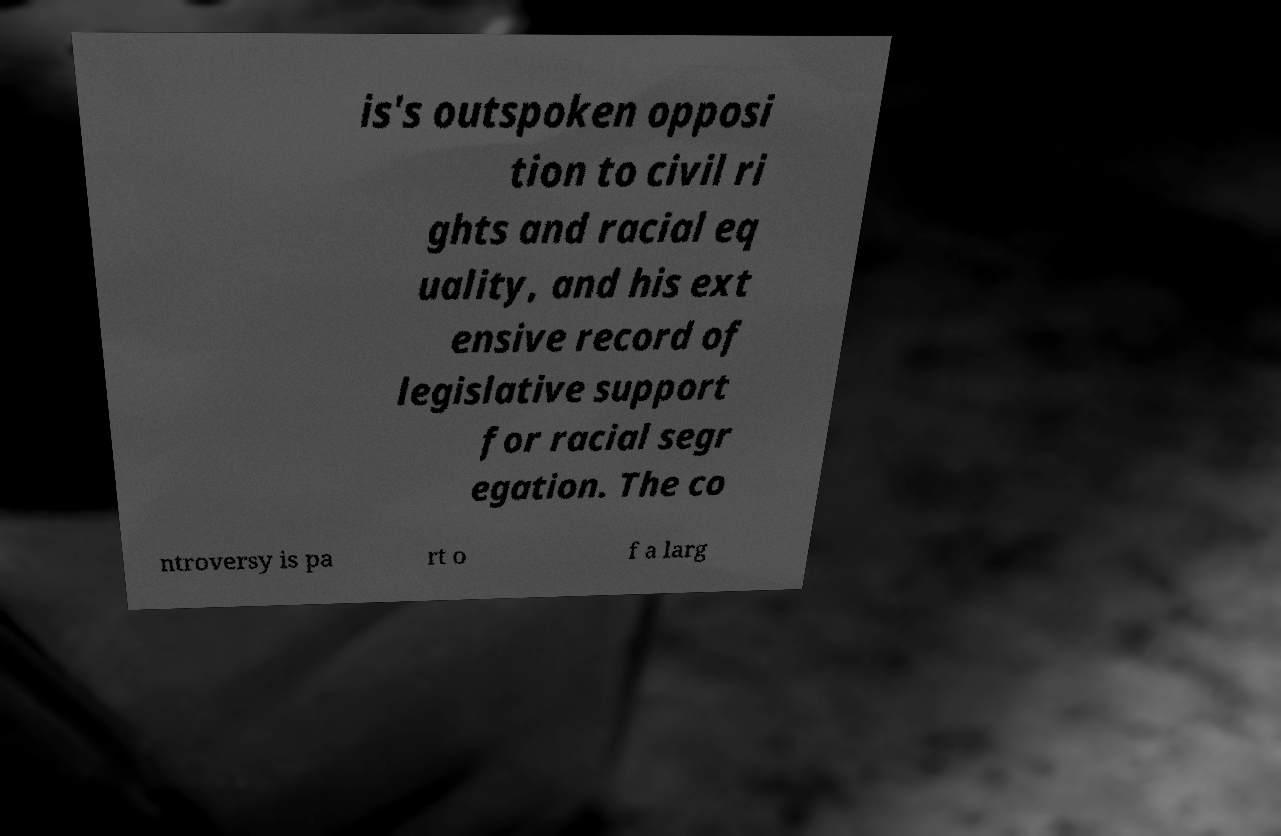Could you extract and type out the text from this image? is's outspoken opposi tion to civil ri ghts and racial eq uality, and his ext ensive record of legislative support for racial segr egation. The co ntroversy is pa rt o f a larg 